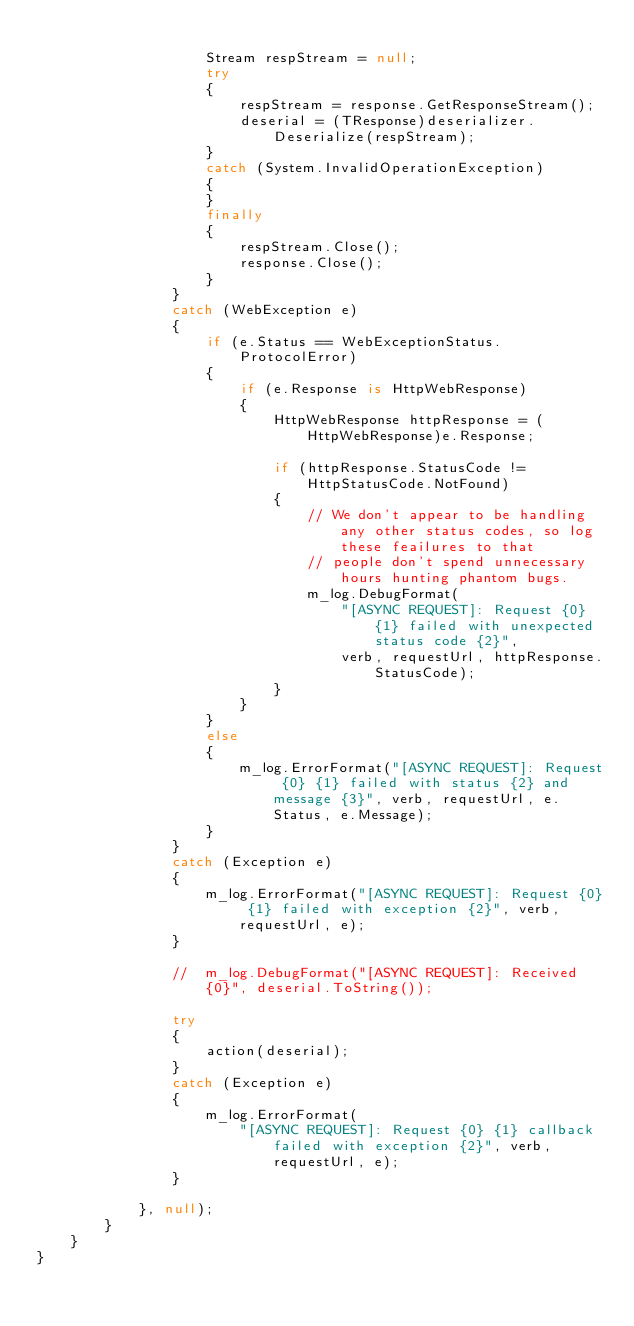<code> <loc_0><loc_0><loc_500><loc_500><_C#_>
                    Stream respStream = null;
                    try
                    {
                        respStream = response.GetResponseStream();
                        deserial = (TResponse)deserializer.Deserialize(respStream);
                    }
                    catch (System.InvalidOperationException)
                    {
                    }
                    finally
                    {
                        respStream.Close();
                        response.Close();
                    }
                }
                catch (WebException e)
                {
                    if (e.Status == WebExceptionStatus.ProtocolError)
                    {
                        if (e.Response is HttpWebResponse)
                        {
                            HttpWebResponse httpResponse = (HttpWebResponse)e.Response;
                        
                            if (httpResponse.StatusCode != HttpStatusCode.NotFound)
                            {
                                // We don't appear to be handling any other status codes, so log these feailures to that
                                // people don't spend unnecessary hours hunting phantom bugs.
                                m_log.DebugFormat(
                                    "[ASYNC REQUEST]: Request {0} {1} failed with unexpected status code {2}", 
                                    verb, requestUrl, httpResponse.StatusCode);
                            }
                        }
                    }
                    else
                    {
                        m_log.ErrorFormat("[ASYNC REQUEST]: Request {0} {1} failed with status {2} and message {3}", verb, requestUrl, e.Status, e.Message);
                    }
                }
                catch (Exception e)
                {
                    m_log.ErrorFormat("[ASYNC REQUEST]: Request {0} {1} failed with exception {2}", verb, requestUrl, e);
                }

                //  m_log.DebugFormat("[ASYNC REQUEST]: Received {0}", deserial.ToString());

                try
                {
                    action(deserial);
                }
                catch (Exception e)
                {
                    m_log.ErrorFormat(
                        "[ASYNC REQUEST]: Request {0} {1} callback failed with exception {2}", verb, requestUrl, e);
                }
                    
            }, null);
        }
    }
}
</code> 